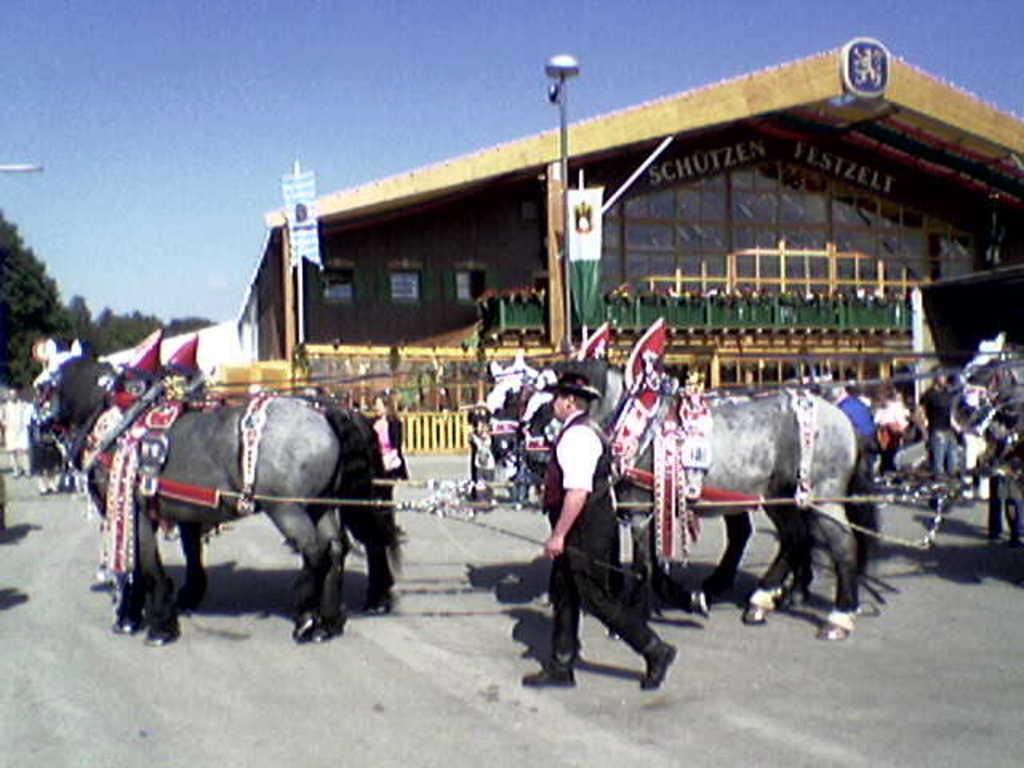Describe this image in one or two sentences. In this image we can see the animals. We can also see the house for shelter. Image also consists of banners, trees, poles, barrier and also the people. In the background we can see the sky and at the bottom we can see the road. 